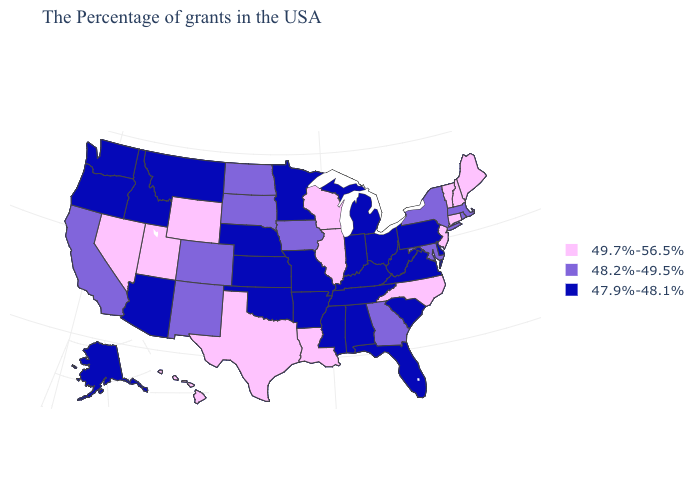What is the value of North Carolina?
Keep it brief. 49.7%-56.5%. What is the value of Arizona?
Answer briefly. 47.9%-48.1%. What is the highest value in the MidWest ?
Concise answer only. 49.7%-56.5%. Does Connecticut have a lower value than Pennsylvania?
Keep it brief. No. Which states have the lowest value in the USA?
Concise answer only. Delaware, Pennsylvania, Virginia, South Carolina, West Virginia, Ohio, Florida, Michigan, Kentucky, Indiana, Alabama, Tennessee, Mississippi, Missouri, Arkansas, Minnesota, Kansas, Nebraska, Oklahoma, Montana, Arizona, Idaho, Washington, Oregon, Alaska. What is the value of Arizona?
Answer briefly. 47.9%-48.1%. Name the states that have a value in the range 48.2%-49.5%?
Keep it brief. Massachusetts, Rhode Island, New York, Maryland, Georgia, Iowa, South Dakota, North Dakota, Colorado, New Mexico, California. Which states hav the highest value in the MidWest?
Be succinct. Wisconsin, Illinois. Name the states that have a value in the range 47.9%-48.1%?
Quick response, please. Delaware, Pennsylvania, Virginia, South Carolina, West Virginia, Ohio, Florida, Michigan, Kentucky, Indiana, Alabama, Tennessee, Mississippi, Missouri, Arkansas, Minnesota, Kansas, Nebraska, Oklahoma, Montana, Arizona, Idaho, Washington, Oregon, Alaska. Name the states that have a value in the range 47.9%-48.1%?
Quick response, please. Delaware, Pennsylvania, Virginia, South Carolina, West Virginia, Ohio, Florida, Michigan, Kentucky, Indiana, Alabama, Tennessee, Mississippi, Missouri, Arkansas, Minnesota, Kansas, Nebraska, Oklahoma, Montana, Arizona, Idaho, Washington, Oregon, Alaska. Which states have the lowest value in the South?
Give a very brief answer. Delaware, Virginia, South Carolina, West Virginia, Florida, Kentucky, Alabama, Tennessee, Mississippi, Arkansas, Oklahoma. Does Utah have the lowest value in the USA?
Short answer required. No. Name the states that have a value in the range 49.7%-56.5%?
Give a very brief answer. Maine, New Hampshire, Vermont, Connecticut, New Jersey, North Carolina, Wisconsin, Illinois, Louisiana, Texas, Wyoming, Utah, Nevada, Hawaii. Among the states that border Mississippi , does Louisiana have the highest value?
Be succinct. Yes. Name the states that have a value in the range 49.7%-56.5%?
Give a very brief answer. Maine, New Hampshire, Vermont, Connecticut, New Jersey, North Carolina, Wisconsin, Illinois, Louisiana, Texas, Wyoming, Utah, Nevada, Hawaii. 